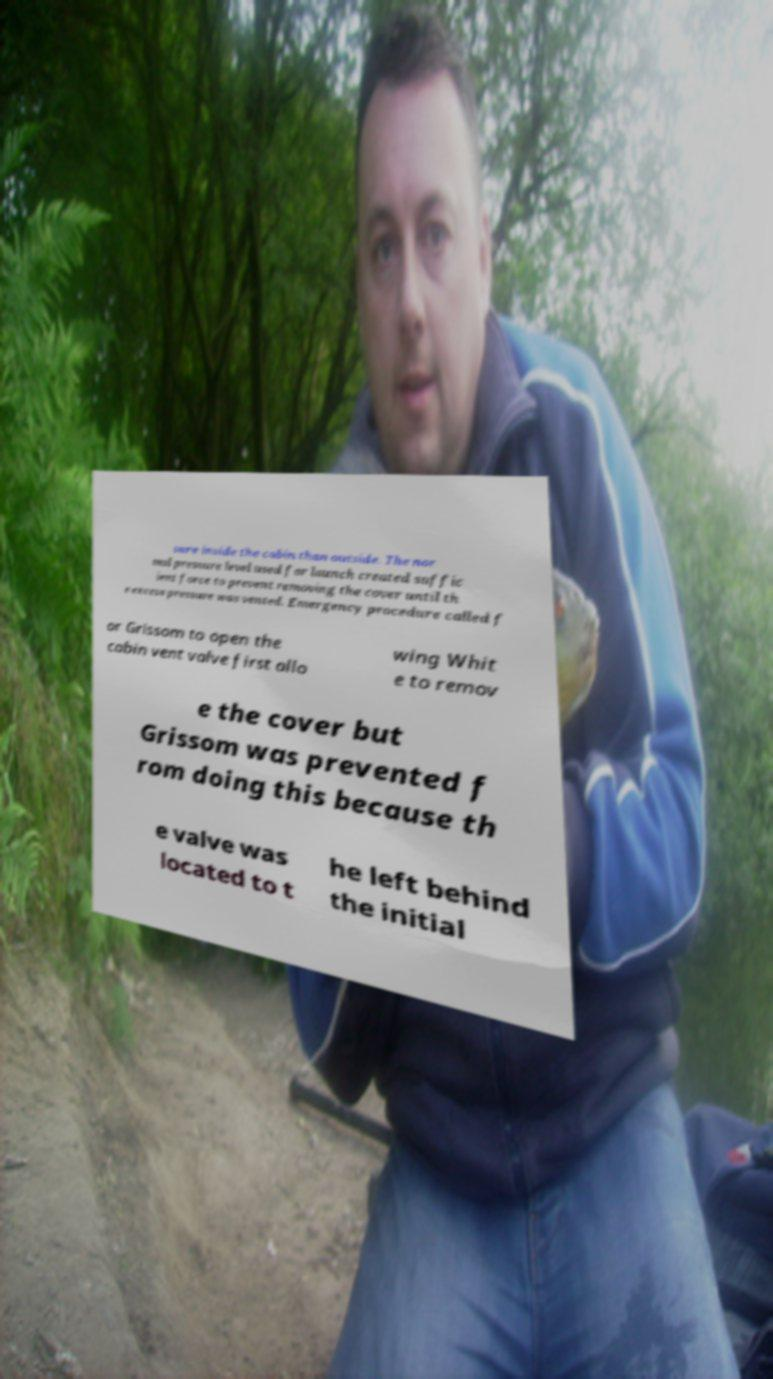Please identify and transcribe the text found in this image. sure inside the cabin than outside. The nor mal pressure level used for launch created suffic ient force to prevent removing the cover until th e excess pressure was vented. Emergency procedure called f or Grissom to open the cabin vent valve first allo wing Whit e to remov e the cover but Grissom was prevented f rom doing this because th e valve was located to t he left behind the initial 